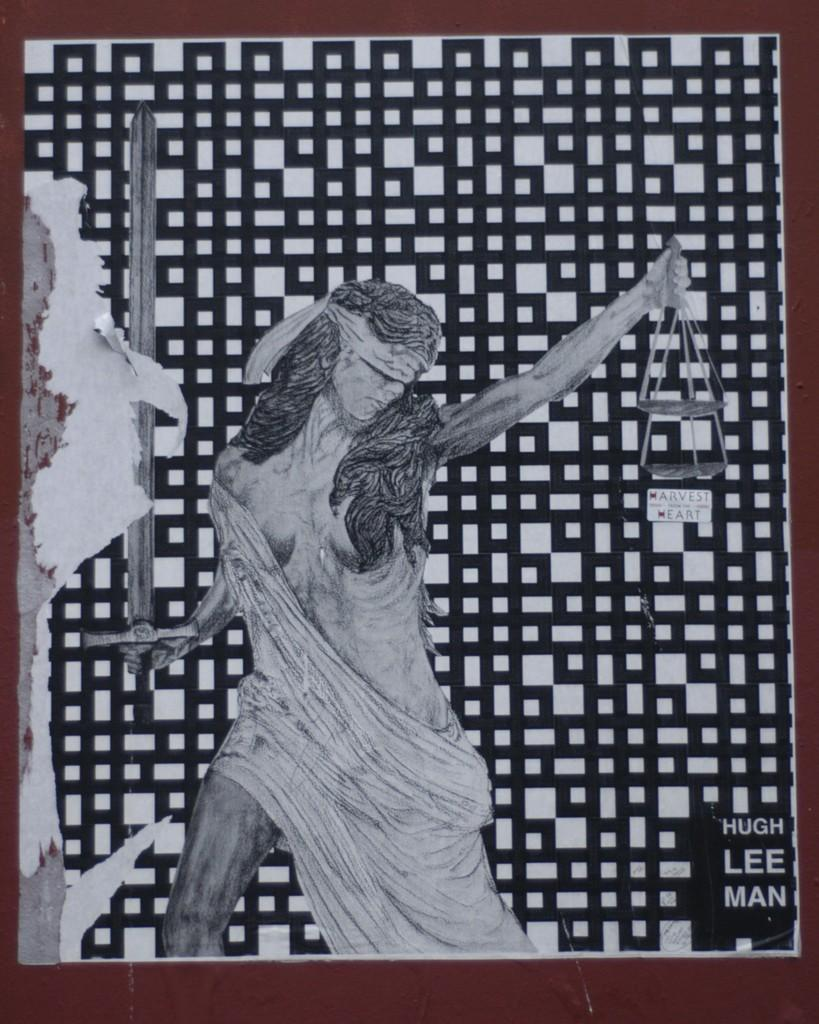Who is the main subject in the image? There is a woman in the image. What is the woman depicted as doing or wearing? The woman is depicted with a blindfold and is holding a sword and a weighing scale. Are there any words or letters in the image? Yes, there is text in the image. How is the image framed or contained? The image has borders. What type of grass can be seen growing in the image? There is no grass present in the image; it features a woman with a blindfold, sword, and weighing scale, along with text and borders. 